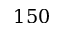<formula> <loc_0><loc_0><loc_500><loc_500>1 5 0</formula> 